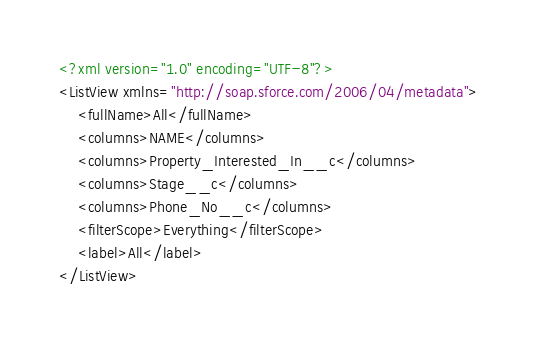<code> <loc_0><loc_0><loc_500><loc_500><_XML_><?xml version="1.0" encoding="UTF-8"?>
<ListView xmlns="http://soap.sforce.com/2006/04/metadata">
    <fullName>All</fullName>
    <columns>NAME</columns>
    <columns>Property_Interested_In__c</columns>
    <columns>Stage__c</columns>
    <columns>Phone_No__c</columns>
    <filterScope>Everything</filterScope>
    <label>All</label>
</ListView>
</code> 